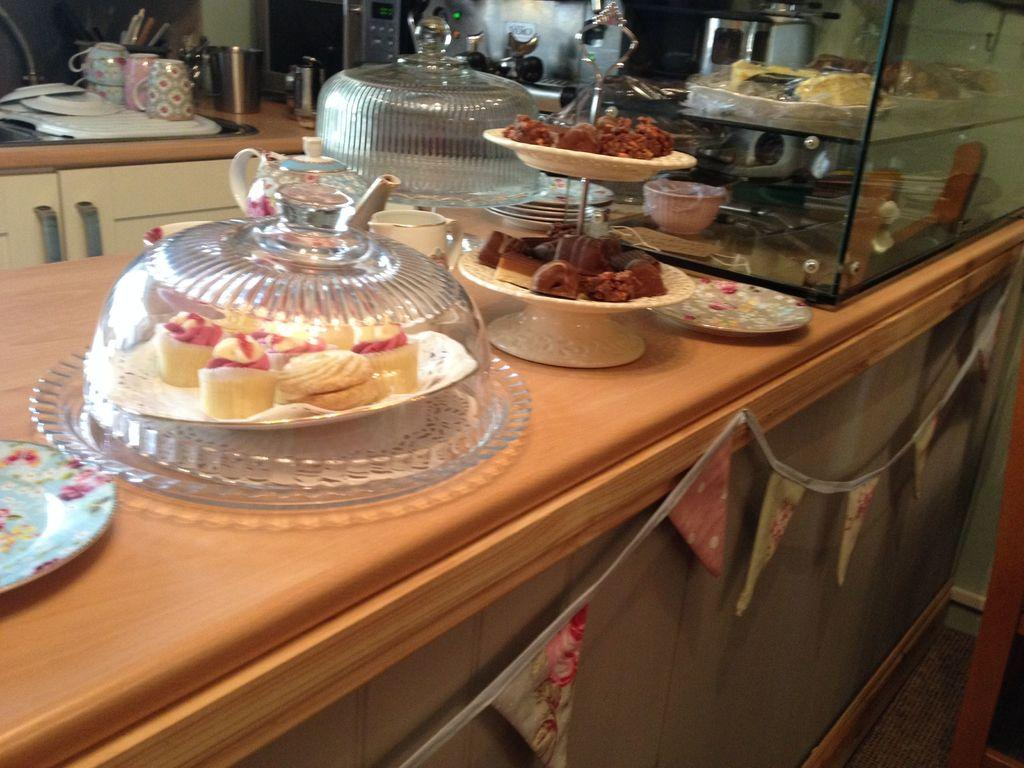What type of furniture is present in the image? There is a table in the image. What is placed on the table? There are food items on the table. What can be used to eat or serve the food? There are utensils in the image. What is used to enhance the visual appeal of the table setting? There is decoration in the image. What type of container is present on the table? There is a glass container in the image. What type of books can be seen in the image? There is no reference to books or a library in the image, so it is not possible to determine what books might be present. 